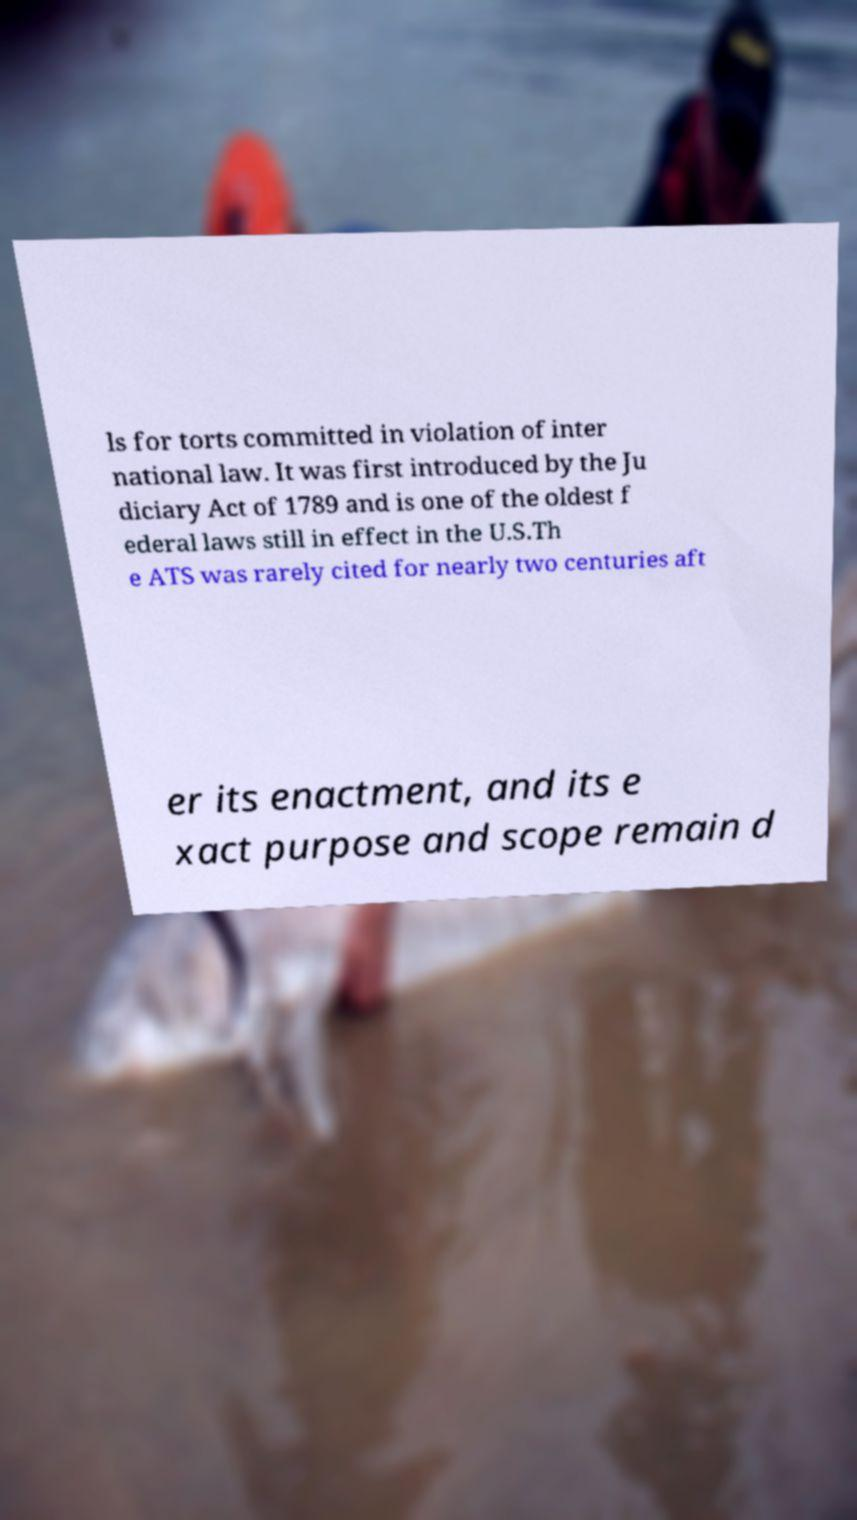Can you accurately transcribe the text from the provided image for me? ls for torts committed in violation of inter national law. It was first introduced by the Ju diciary Act of 1789 and is one of the oldest f ederal laws still in effect in the U.S.Th e ATS was rarely cited for nearly two centuries aft er its enactment, and its e xact purpose and scope remain d 